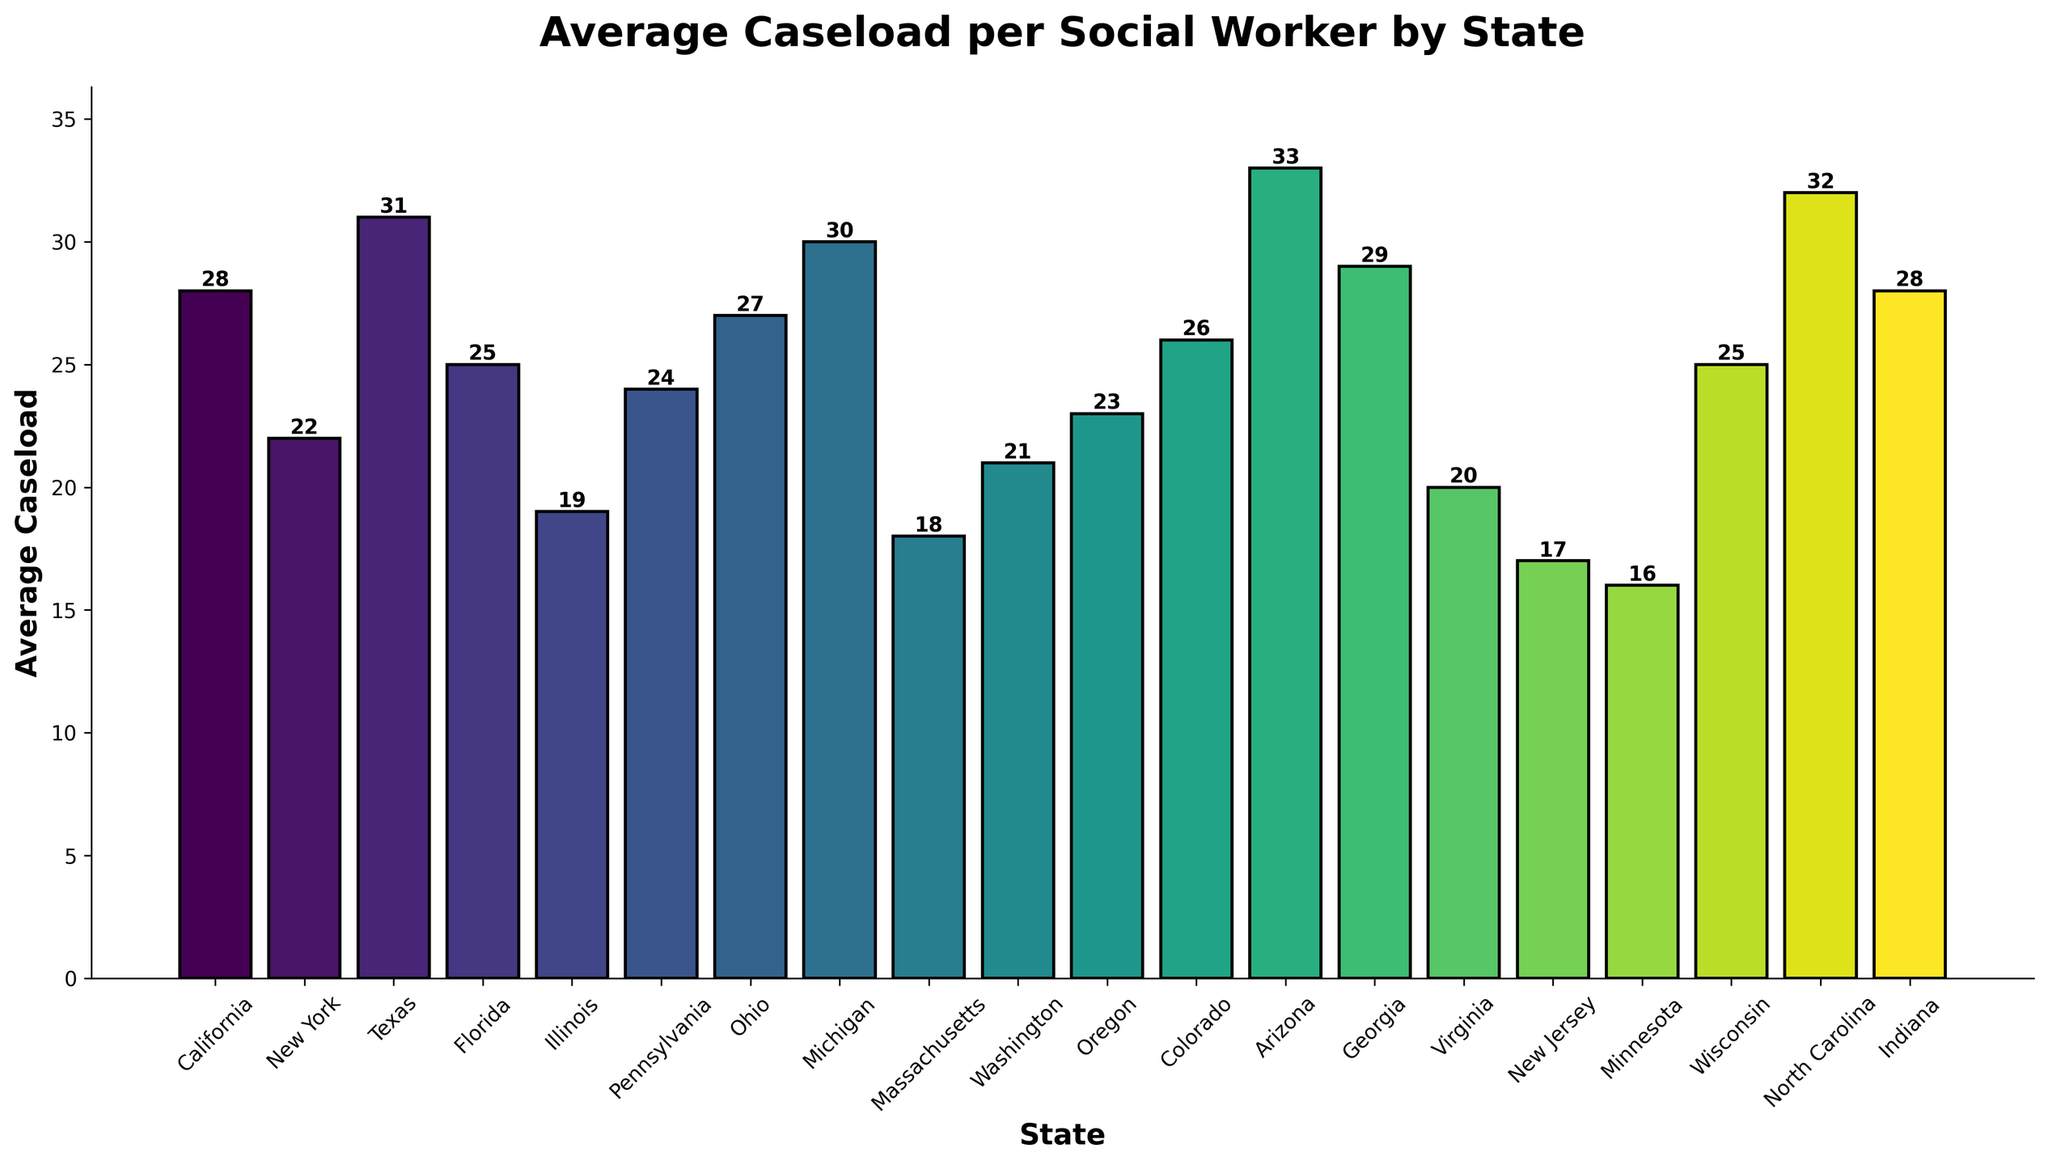What is the state with the highest average caseload per social worker? To determine the state with the highest average caseload, look at the bar heights in the chart and identify the tallest bar. In this case, the tallest bar corresponds to Arizona with an average caseload of 33.
Answer: Arizona What is the total average caseload for California, Texas, and Michigan combined? First, find the average caseloads from the chart: California (28), Texas (31), and Michigan (30). Then, sum these values: 28 + 31 + 30 = 89.
Answer: 89 How many more average caseloads does North Carolina have compared to Massachusetts? North Carolina's average caseload is 32, and Massachusetts' is 18. Subtract the two values: 32 - 18 = 14.
Answer: 14 Is Ohio’s average caseload higher or lower than Oregon’s? From the chart, Ohio's average caseload is 27 and Oregon's is 23. Since 27 is greater than 23, Ohio’s average caseload is higher.
Answer: Higher What are the two states with the lowest average caseloads? To find the states with the lowest average caseloads, look for the smallest bars in the chart. The states are Minnesota (16) and New Jersey (17).
Answer: Minnesota, New Jersey What is the difference in average caseload between Georgia and Florida? Georgia has an average caseload of 29, and Florida has 25. Subtract Florida's caseload from Georgia's: 29 - 25 = 4.
Answer: 4 What is the average caseload across all the states shown on the chart? First, sum the average caseloads for all the states: 28 + 22 + 31 + 25 + 19 + 24 + 27 + 30 + 18 + 21 + 23 + 26 + 33 + 29 + 20 + 17 + 16 + 25 + 32 + 28 = 446. There are 20 states, so divide by 20: 446 / 20 = 22.3.
Answer: 22.3 Which states have an average caseload that is closer to the national average of 20 cases per social worker? Look for states with caseloads nearest to 20 in the chart. These states are Washington (21) and Virginia (20).
Answer: Washington, Virginia How many states have an average caseload above 25? To find the number of states with average caseloads above 25, count the bars where the height indicates a value greater than 25. These states are Texas (31), Michigan (30), Arizona (33), Georgia (29), North Carolina (32), and Indiana (28), totaling 6 states.
Answer: 6 